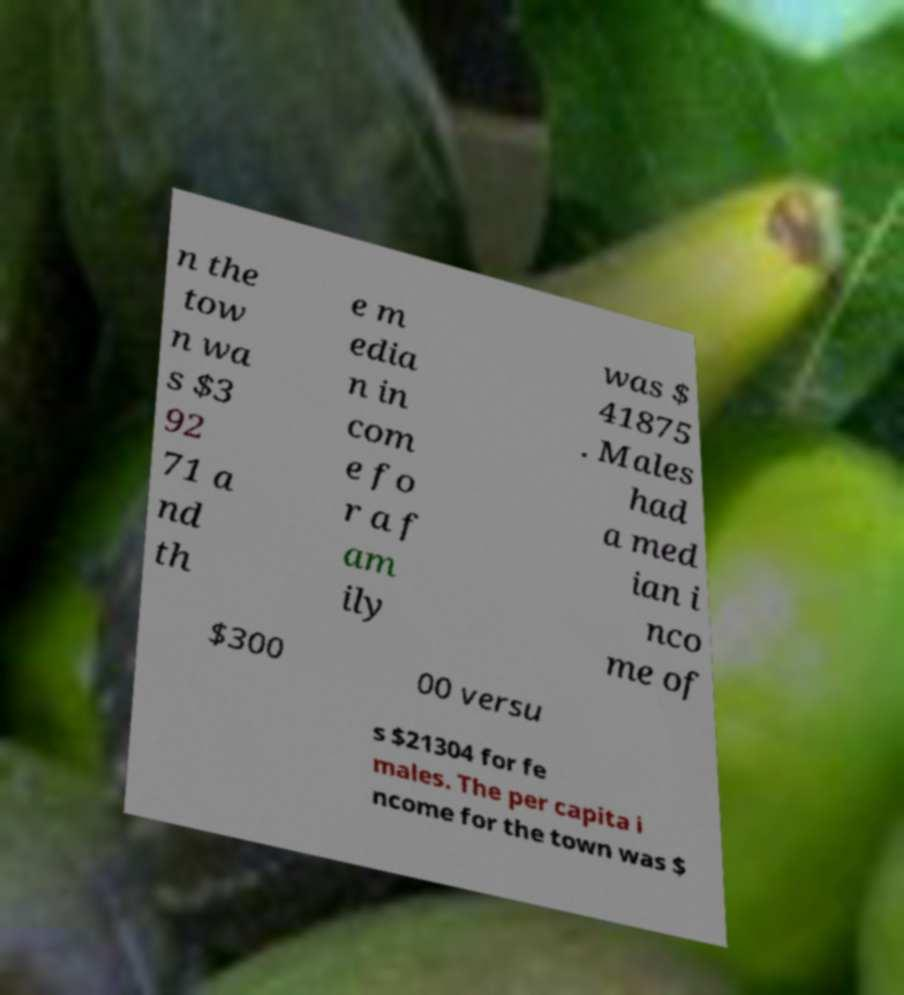Can you accurately transcribe the text from the provided image for me? n the tow n wa s $3 92 71 a nd th e m edia n in com e fo r a f am ily was $ 41875 . Males had a med ian i nco me of $300 00 versu s $21304 for fe males. The per capita i ncome for the town was $ 